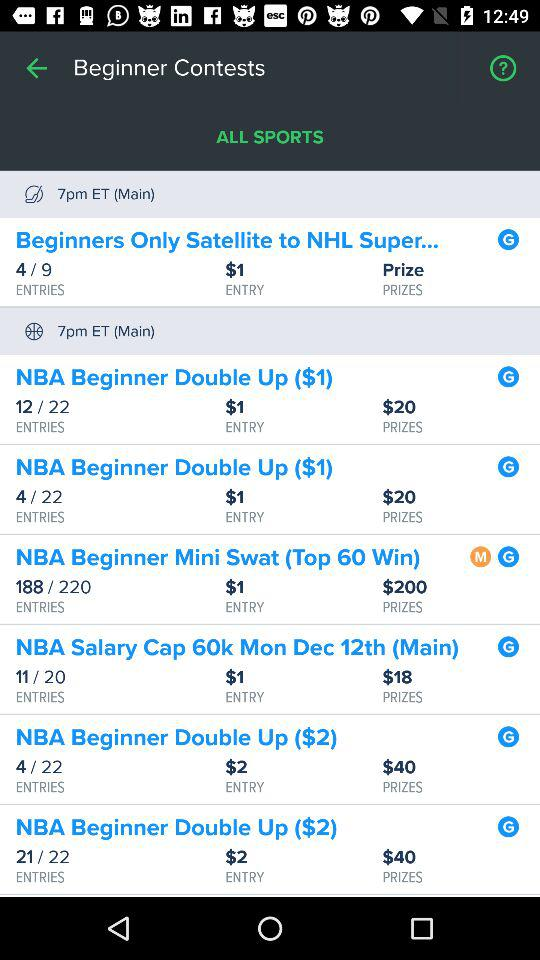How much will one have to pay to get entry into the "NBA Beginner Mini Swat"? One has to pay $1 to get entry into the "NBA Beginner Mini Swat". 